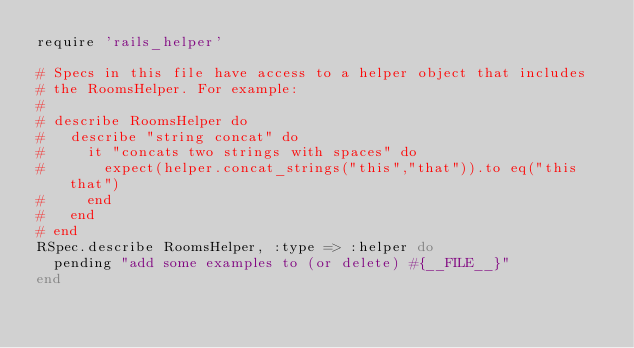Convert code to text. <code><loc_0><loc_0><loc_500><loc_500><_Ruby_>require 'rails_helper'

# Specs in this file have access to a helper object that includes
# the RoomsHelper. For example:
#
# describe RoomsHelper do
#   describe "string concat" do
#     it "concats two strings with spaces" do
#       expect(helper.concat_strings("this","that")).to eq("this that")
#     end
#   end
# end
RSpec.describe RoomsHelper, :type => :helper do
  pending "add some examples to (or delete) #{__FILE__}"
end
</code> 